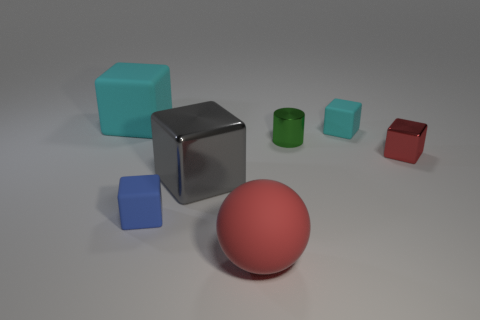Subtract all red cubes. How many cubes are left? 4 Subtract all blue rubber cubes. How many cubes are left? 4 Subtract all purple blocks. Subtract all cyan spheres. How many blocks are left? 5 Add 1 cyan rubber objects. How many objects exist? 8 Subtract all spheres. How many objects are left? 6 Subtract 0 yellow blocks. How many objects are left? 7 Subtract all big red shiny spheres. Subtract all big rubber objects. How many objects are left? 5 Add 2 tiny shiny blocks. How many tiny shiny blocks are left? 3 Add 3 big green cylinders. How many big green cylinders exist? 3 